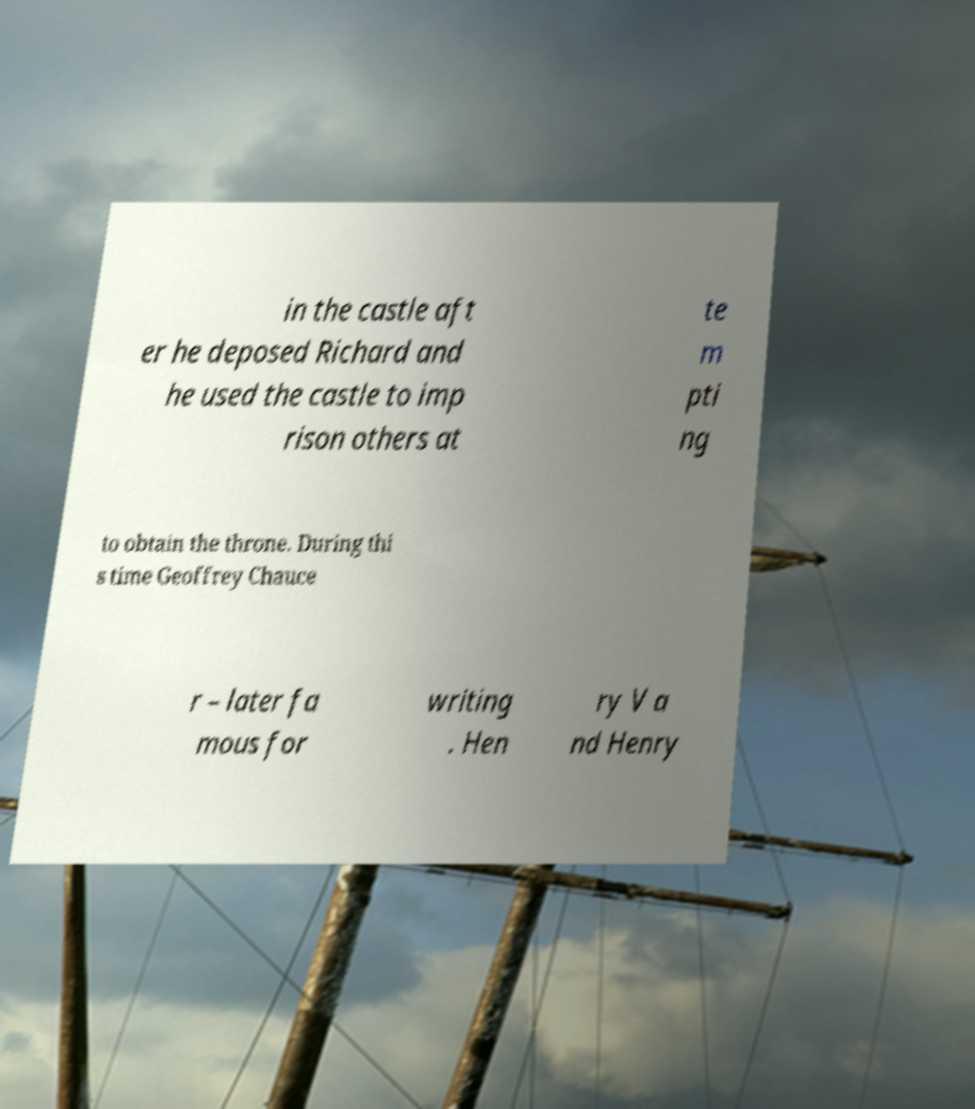I need the written content from this picture converted into text. Can you do that? in the castle aft er he deposed Richard and he used the castle to imp rison others at te m pti ng to obtain the throne. During thi s time Geoffrey Chauce r – later fa mous for writing . Hen ry V a nd Henry 